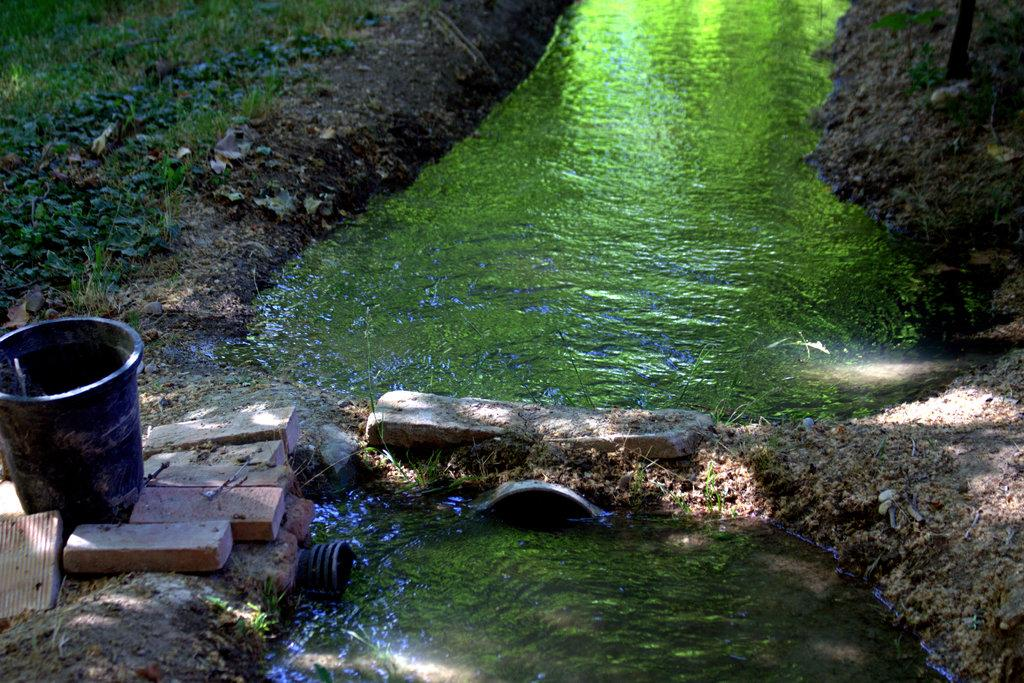What object is present in the image that can hold or store items? There is a container in the image. What type of building material can be seen in the image? There are bricks in the image. What type of vegetation is on the left side of the image? There is grass on the left side of the image. What natural element is in the center of the image? There is water in the center of the image. What type of chalk is being used to write on the grass in the image? There is no chalk present in the image, and no writing on the grass is visible. What prose is being recited by the bricks in the image? There is no prose being recited by the bricks in the image, as bricks are inanimate objects and cannot recite anything. 